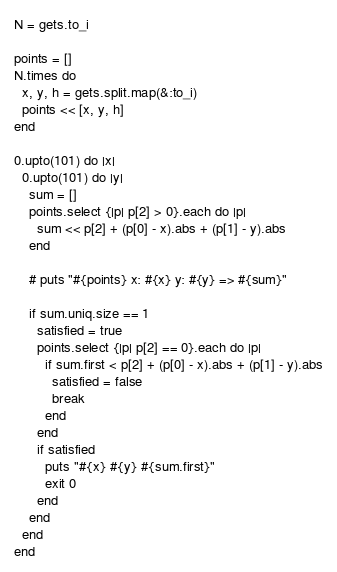Convert code to text. <code><loc_0><loc_0><loc_500><loc_500><_Ruby_>N = gets.to_i

points = []
N.times do
  x, y, h = gets.split.map(&:to_i)
  points << [x, y, h]
end

0.upto(101) do |x|
  0.upto(101) do |y|
    sum = []
    points.select {|p| p[2] > 0}.each do |p|
      sum << p[2] + (p[0] - x).abs + (p[1] - y).abs
    end

    # puts "#{points} x: #{x} y: #{y} => #{sum}"

    if sum.uniq.size == 1
      satisfied = true
      points.select {|p| p[2] == 0}.each do |p|
        if sum.first < p[2] + (p[0] - x).abs + (p[1] - y).abs
          satisfied = false
          break
        end
      end
      if satisfied
        puts "#{x} #{y} #{sum.first}"
        exit 0
      end
    end
  end
end
</code> 